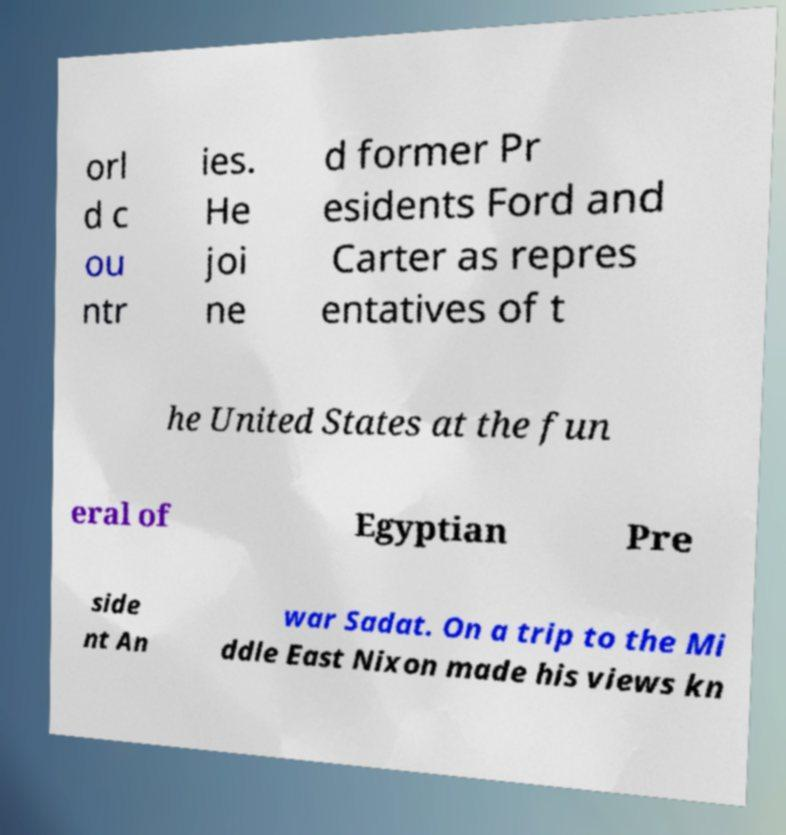Could you assist in decoding the text presented in this image and type it out clearly? orl d c ou ntr ies. He joi ne d former Pr esidents Ford and Carter as repres entatives of t he United States at the fun eral of Egyptian Pre side nt An war Sadat. On a trip to the Mi ddle East Nixon made his views kn 